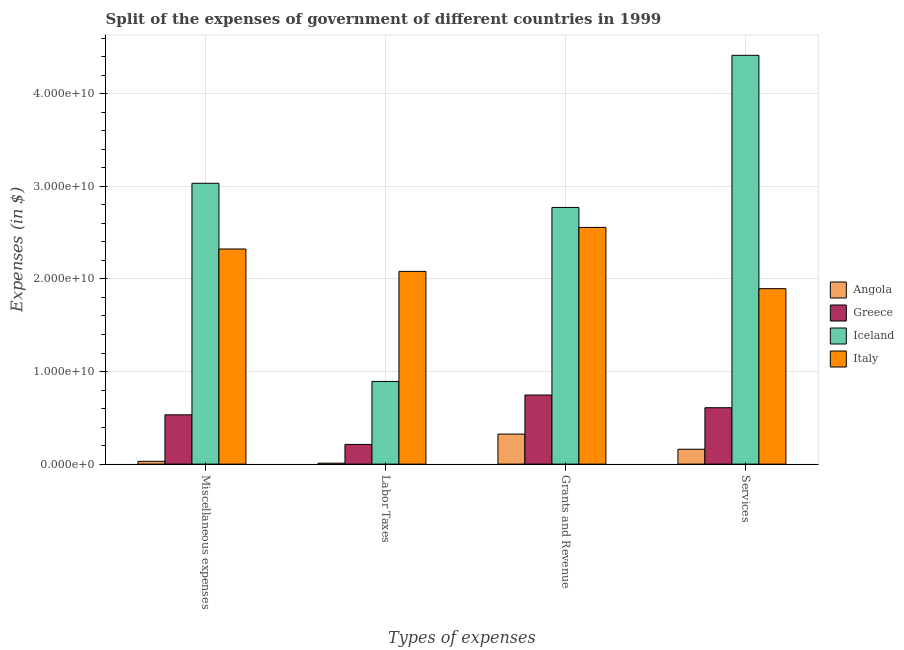How many bars are there on the 1st tick from the right?
Keep it short and to the point. 4. What is the label of the 4th group of bars from the left?
Give a very brief answer. Services. What is the amount spent on grants and revenue in Italy?
Provide a succinct answer. 2.56e+1. Across all countries, what is the maximum amount spent on miscellaneous expenses?
Ensure brevity in your answer.  3.03e+1. Across all countries, what is the minimum amount spent on miscellaneous expenses?
Give a very brief answer. 3.02e+08. In which country was the amount spent on labor taxes maximum?
Provide a succinct answer. Italy. In which country was the amount spent on grants and revenue minimum?
Your answer should be compact. Angola. What is the total amount spent on miscellaneous expenses in the graph?
Make the answer very short. 5.92e+1. What is the difference between the amount spent on grants and revenue in Iceland and that in Angola?
Give a very brief answer. 2.45e+1. What is the difference between the amount spent on labor taxes in Angola and the amount spent on grants and revenue in Italy?
Your response must be concise. -2.55e+1. What is the average amount spent on miscellaneous expenses per country?
Your answer should be compact. 1.48e+1. What is the difference between the amount spent on services and amount spent on labor taxes in Angola?
Your answer should be very brief. 1.50e+09. In how many countries, is the amount spent on miscellaneous expenses greater than 22000000000 $?
Make the answer very short. 2. What is the ratio of the amount spent on labor taxes in Greece to that in Iceland?
Offer a very short reply. 0.24. Is the amount spent on labor taxes in Angola less than that in Greece?
Your answer should be compact. Yes. Is the difference between the amount spent on miscellaneous expenses in Italy and Greece greater than the difference between the amount spent on grants and revenue in Italy and Greece?
Ensure brevity in your answer.  No. What is the difference between the highest and the second highest amount spent on grants and revenue?
Your answer should be very brief. 2.16e+09. What is the difference between the highest and the lowest amount spent on grants and revenue?
Provide a succinct answer. 2.45e+1. In how many countries, is the amount spent on miscellaneous expenses greater than the average amount spent on miscellaneous expenses taken over all countries?
Your response must be concise. 2. What does the 1st bar from the left in Services represents?
Ensure brevity in your answer.  Angola. Is it the case that in every country, the sum of the amount spent on miscellaneous expenses and amount spent on labor taxes is greater than the amount spent on grants and revenue?
Make the answer very short. No. How many countries are there in the graph?
Offer a terse response. 4. Are the values on the major ticks of Y-axis written in scientific E-notation?
Give a very brief answer. Yes. Does the graph contain grids?
Offer a terse response. Yes. How are the legend labels stacked?
Your answer should be very brief. Vertical. What is the title of the graph?
Ensure brevity in your answer.  Split of the expenses of government of different countries in 1999. Does "United States" appear as one of the legend labels in the graph?
Ensure brevity in your answer.  No. What is the label or title of the X-axis?
Make the answer very short. Types of expenses. What is the label or title of the Y-axis?
Ensure brevity in your answer.  Expenses (in $). What is the Expenses (in $) of Angola in Miscellaneous expenses?
Ensure brevity in your answer.  3.02e+08. What is the Expenses (in $) in Greece in Miscellaneous expenses?
Offer a very short reply. 5.32e+09. What is the Expenses (in $) of Iceland in Miscellaneous expenses?
Give a very brief answer. 3.03e+1. What is the Expenses (in $) in Italy in Miscellaneous expenses?
Your response must be concise. 2.32e+1. What is the Expenses (in $) in Angola in Labor Taxes?
Provide a succinct answer. 1.02e+08. What is the Expenses (in $) in Greece in Labor Taxes?
Give a very brief answer. 2.13e+09. What is the Expenses (in $) in Iceland in Labor Taxes?
Your answer should be very brief. 8.93e+09. What is the Expenses (in $) of Italy in Labor Taxes?
Your answer should be compact. 2.08e+1. What is the Expenses (in $) in Angola in Grants and Revenue?
Offer a terse response. 3.24e+09. What is the Expenses (in $) of Greece in Grants and Revenue?
Your answer should be very brief. 7.46e+09. What is the Expenses (in $) in Iceland in Grants and Revenue?
Keep it short and to the point. 2.77e+1. What is the Expenses (in $) of Italy in Grants and Revenue?
Make the answer very short. 2.56e+1. What is the Expenses (in $) of Angola in Services?
Provide a succinct answer. 1.61e+09. What is the Expenses (in $) of Greece in Services?
Offer a very short reply. 6.09e+09. What is the Expenses (in $) in Iceland in Services?
Offer a terse response. 4.42e+1. What is the Expenses (in $) of Italy in Services?
Offer a very short reply. 1.89e+1. Across all Types of expenses, what is the maximum Expenses (in $) in Angola?
Your answer should be compact. 3.24e+09. Across all Types of expenses, what is the maximum Expenses (in $) of Greece?
Ensure brevity in your answer.  7.46e+09. Across all Types of expenses, what is the maximum Expenses (in $) in Iceland?
Make the answer very short. 4.42e+1. Across all Types of expenses, what is the maximum Expenses (in $) in Italy?
Your answer should be very brief. 2.56e+1. Across all Types of expenses, what is the minimum Expenses (in $) of Angola?
Provide a short and direct response. 1.02e+08. Across all Types of expenses, what is the minimum Expenses (in $) of Greece?
Make the answer very short. 2.13e+09. Across all Types of expenses, what is the minimum Expenses (in $) in Iceland?
Keep it short and to the point. 8.93e+09. Across all Types of expenses, what is the minimum Expenses (in $) of Italy?
Your answer should be compact. 1.89e+1. What is the total Expenses (in $) of Angola in the graph?
Make the answer very short. 5.25e+09. What is the total Expenses (in $) in Greece in the graph?
Keep it short and to the point. 2.10e+1. What is the total Expenses (in $) in Iceland in the graph?
Ensure brevity in your answer.  1.11e+11. What is the total Expenses (in $) of Italy in the graph?
Offer a very short reply. 8.86e+1. What is the difference between the Expenses (in $) in Angola in Miscellaneous expenses and that in Labor Taxes?
Offer a very short reply. 2.01e+08. What is the difference between the Expenses (in $) in Greece in Miscellaneous expenses and that in Labor Taxes?
Your answer should be compact. 3.20e+09. What is the difference between the Expenses (in $) in Iceland in Miscellaneous expenses and that in Labor Taxes?
Keep it short and to the point. 2.14e+1. What is the difference between the Expenses (in $) of Italy in Miscellaneous expenses and that in Labor Taxes?
Offer a terse response. 2.42e+09. What is the difference between the Expenses (in $) of Angola in Miscellaneous expenses and that in Grants and Revenue?
Your answer should be compact. -2.94e+09. What is the difference between the Expenses (in $) in Greece in Miscellaneous expenses and that in Grants and Revenue?
Your response must be concise. -2.14e+09. What is the difference between the Expenses (in $) of Iceland in Miscellaneous expenses and that in Grants and Revenue?
Provide a short and direct response. 2.61e+09. What is the difference between the Expenses (in $) of Italy in Miscellaneous expenses and that in Grants and Revenue?
Give a very brief answer. -2.33e+09. What is the difference between the Expenses (in $) in Angola in Miscellaneous expenses and that in Services?
Make the answer very short. -1.30e+09. What is the difference between the Expenses (in $) of Greece in Miscellaneous expenses and that in Services?
Ensure brevity in your answer.  -7.66e+08. What is the difference between the Expenses (in $) of Iceland in Miscellaneous expenses and that in Services?
Your answer should be very brief. -1.38e+1. What is the difference between the Expenses (in $) in Italy in Miscellaneous expenses and that in Services?
Your answer should be very brief. 4.28e+09. What is the difference between the Expenses (in $) in Angola in Labor Taxes and that in Grants and Revenue?
Provide a short and direct response. -3.14e+09. What is the difference between the Expenses (in $) of Greece in Labor Taxes and that in Grants and Revenue?
Provide a succinct answer. -5.33e+09. What is the difference between the Expenses (in $) in Iceland in Labor Taxes and that in Grants and Revenue?
Give a very brief answer. -1.88e+1. What is the difference between the Expenses (in $) of Italy in Labor Taxes and that in Grants and Revenue?
Keep it short and to the point. -4.75e+09. What is the difference between the Expenses (in $) in Angola in Labor Taxes and that in Services?
Provide a succinct answer. -1.50e+09. What is the difference between the Expenses (in $) in Greece in Labor Taxes and that in Services?
Ensure brevity in your answer.  -3.96e+09. What is the difference between the Expenses (in $) in Iceland in Labor Taxes and that in Services?
Make the answer very short. -3.52e+1. What is the difference between the Expenses (in $) in Italy in Labor Taxes and that in Services?
Provide a succinct answer. 1.87e+09. What is the difference between the Expenses (in $) in Angola in Grants and Revenue and that in Services?
Offer a very short reply. 1.64e+09. What is the difference between the Expenses (in $) of Greece in Grants and Revenue and that in Services?
Offer a terse response. 1.37e+09. What is the difference between the Expenses (in $) of Iceland in Grants and Revenue and that in Services?
Make the answer very short. -1.64e+1. What is the difference between the Expenses (in $) of Italy in Grants and Revenue and that in Services?
Ensure brevity in your answer.  6.62e+09. What is the difference between the Expenses (in $) of Angola in Miscellaneous expenses and the Expenses (in $) of Greece in Labor Taxes?
Keep it short and to the point. -1.83e+09. What is the difference between the Expenses (in $) of Angola in Miscellaneous expenses and the Expenses (in $) of Iceland in Labor Taxes?
Offer a very short reply. -8.63e+09. What is the difference between the Expenses (in $) of Angola in Miscellaneous expenses and the Expenses (in $) of Italy in Labor Taxes?
Your answer should be compact. -2.05e+1. What is the difference between the Expenses (in $) in Greece in Miscellaneous expenses and the Expenses (in $) in Iceland in Labor Taxes?
Offer a very short reply. -3.61e+09. What is the difference between the Expenses (in $) in Greece in Miscellaneous expenses and the Expenses (in $) in Italy in Labor Taxes?
Ensure brevity in your answer.  -1.55e+1. What is the difference between the Expenses (in $) of Iceland in Miscellaneous expenses and the Expenses (in $) of Italy in Labor Taxes?
Make the answer very short. 9.52e+09. What is the difference between the Expenses (in $) in Angola in Miscellaneous expenses and the Expenses (in $) in Greece in Grants and Revenue?
Offer a terse response. -7.16e+09. What is the difference between the Expenses (in $) of Angola in Miscellaneous expenses and the Expenses (in $) of Iceland in Grants and Revenue?
Provide a succinct answer. -2.74e+1. What is the difference between the Expenses (in $) of Angola in Miscellaneous expenses and the Expenses (in $) of Italy in Grants and Revenue?
Provide a succinct answer. -2.53e+1. What is the difference between the Expenses (in $) in Greece in Miscellaneous expenses and the Expenses (in $) in Iceland in Grants and Revenue?
Offer a very short reply. -2.24e+1. What is the difference between the Expenses (in $) of Greece in Miscellaneous expenses and the Expenses (in $) of Italy in Grants and Revenue?
Make the answer very short. -2.02e+1. What is the difference between the Expenses (in $) in Iceland in Miscellaneous expenses and the Expenses (in $) in Italy in Grants and Revenue?
Provide a succinct answer. 4.77e+09. What is the difference between the Expenses (in $) of Angola in Miscellaneous expenses and the Expenses (in $) of Greece in Services?
Offer a very short reply. -5.79e+09. What is the difference between the Expenses (in $) in Angola in Miscellaneous expenses and the Expenses (in $) in Iceland in Services?
Give a very brief answer. -4.39e+1. What is the difference between the Expenses (in $) in Angola in Miscellaneous expenses and the Expenses (in $) in Italy in Services?
Your answer should be very brief. -1.86e+1. What is the difference between the Expenses (in $) of Greece in Miscellaneous expenses and the Expenses (in $) of Iceland in Services?
Ensure brevity in your answer.  -3.88e+1. What is the difference between the Expenses (in $) of Greece in Miscellaneous expenses and the Expenses (in $) of Italy in Services?
Offer a very short reply. -1.36e+1. What is the difference between the Expenses (in $) of Iceland in Miscellaneous expenses and the Expenses (in $) of Italy in Services?
Your response must be concise. 1.14e+1. What is the difference between the Expenses (in $) in Angola in Labor Taxes and the Expenses (in $) in Greece in Grants and Revenue?
Give a very brief answer. -7.36e+09. What is the difference between the Expenses (in $) of Angola in Labor Taxes and the Expenses (in $) of Iceland in Grants and Revenue?
Give a very brief answer. -2.76e+1. What is the difference between the Expenses (in $) in Angola in Labor Taxes and the Expenses (in $) in Italy in Grants and Revenue?
Make the answer very short. -2.55e+1. What is the difference between the Expenses (in $) of Greece in Labor Taxes and the Expenses (in $) of Iceland in Grants and Revenue?
Provide a succinct answer. -2.56e+1. What is the difference between the Expenses (in $) of Greece in Labor Taxes and the Expenses (in $) of Italy in Grants and Revenue?
Offer a very short reply. -2.34e+1. What is the difference between the Expenses (in $) in Iceland in Labor Taxes and the Expenses (in $) in Italy in Grants and Revenue?
Ensure brevity in your answer.  -1.66e+1. What is the difference between the Expenses (in $) of Angola in Labor Taxes and the Expenses (in $) of Greece in Services?
Your answer should be compact. -5.99e+09. What is the difference between the Expenses (in $) in Angola in Labor Taxes and the Expenses (in $) in Iceland in Services?
Offer a terse response. -4.41e+1. What is the difference between the Expenses (in $) in Angola in Labor Taxes and the Expenses (in $) in Italy in Services?
Make the answer very short. -1.88e+1. What is the difference between the Expenses (in $) of Greece in Labor Taxes and the Expenses (in $) of Iceland in Services?
Keep it short and to the point. -4.20e+1. What is the difference between the Expenses (in $) in Greece in Labor Taxes and the Expenses (in $) in Italy in Services?
Keep it short and to the point. -1.68e+1. What is the difference between the Expenses (in $) in Iceland in Labor Taxes and the Expenses (in $) in Italy in Services?
Provide a short and direct response. -1.00e+1. What is the difference between the Expenses (in $) of Angola in Grants and Revenue and the Expenses (in $) of Greece in Services?
Keep it short and to the point. -2.85e+09. What is the difference between the Expenses (in $) in Angola in Grants and Revenue and the Expenses (in $) in Iceland in Services?
Provide a succinct answer. -4.09e+1. What is the difference between the Expenses (in $) of Angola in Grants and Revenue and the Expenses (in $) of Italy in Services?
Your answer should be compact. -1.57e+1. What is the difference between the Expenses (in $) of Greece in Grants and Revenue and the Expenses (in $) of Iceland in Services?
Offer a terse response. -3.67e+1. What is the difference between the Expenses (in $) in Greece in Grants and Revenue and the Expenses (in $) in Italy in Services?
Your answer should be very brief. -1.15e+1. What is the difference between the Expenses (in $) in Iceland in Grants and Revenue and the Expenses (in $) in Italy in Services?
Make the answer very short. 8.77e+09. What is the average Expenses (in $) of Angola per Types of expenses?
Your answer should be very brief. 1.31e+09. What is the average Expenses (in $) in Greece per Types of expenses?
Ensure brevity in your answer.  5.25e+09. What is the average Expenses (in $) of Iceland per Types of expenses?
Provide a short and direct response. 2.78e+1. What is the average Expenses (in $) in Italy per Types of expenses?
Offer a terse response. 2.21e+1. What is the difference between the Expenses (in $) in Angola and Expenses (in $) in Greece in Miscellaneous expenses?
Give a very brief answer. -5.02e+09. What is the difference between the Expenses (in $) in Angola and Expenses (in $) in Iceland in Miscellaneous expenses?
Give a very brief answer. -3.00e+1. What is the difference between the Expenses (in $) in Angola and Expenses (in $) in Italy in Miscellaneous expenses?
Offer a very short reply. -2.29e+1. What is the difference between the Expenses (in $) of Greece and Expenses (in $) of Iceland in Miscellaneous expenses?
Offer a very short reply. -2.50e+1. What is the difference between the Expenses (in $) of Greece and Expenses (in $) of Italy in Miscellaneous expenses?
Your answer should be very brief. -1.79e+1. What is the difference between the Expenses (in $) in Iceland and Expenses (in $) in Italy in Miscellaneous expenses?
Give a very brief answer. 7.10e+09. What is the difference between the Expenses (in $) of Angola and Expenses (in $) of Greece in Labor Taxes?
Offer a very short reply. -2.03e+09. What is the difference between the Expenses (in $) in Angola and Expenses (in $) in Iceland in Labor Taxes?
Make the answer very short. -8.83e+09. What is the difference between the Expenses (in $) in Angola and Expenses (in $) in Italy in Labor Taxes?
Offer a terse response. -2.07e+1. What is the difference between the Expenses (in $) of Greece and Expenses (in $) of Iceland in Labor Taxes?
Your answer should be compact. -6.80e+09. What is the difference between the Expenses (in $) of Greece and Expenses (in $) of Italy in Labor Taxes?
Keep it short and to the point. -1.87e+1. What is the difference between the Expenses (in $) of Iceland and Expenses (in $) of Italy in Labor Taxes?
Provide a succinct answer. -1.19e+1. What is the difference between the Expenses (in $) of Angola and Expenses (in $) of Greece in Grants and Revenue?
Your answer should be very brief. -4.22e+09. What is the difference between the Expenses (in $) of Angola and Expenses (in $) of Iceland in Grants and Revenue?
Give a very brief answer. -2.45e+1. What is the difference between the Expenses (in $) of Angola and Expenses (in $) of Italy in Grants and Revenue?
Offer a terse response. -2.23e+1. What is the difference between the Expenses (in $) of Greece and Expenses (in $) of Iceland in Grants and Revenue?
Offer a terse response. -2.03e+1. What is the difference between the Expenses (in $) in Greece and Expenses (in $) in Italy in Grants and Revenue?
Your answer should be very brief. -1.81e+1. What is the difference between the Expenses (in $) in Iceland and Expenses (in $) in Italy in Grants and Revenue?
Provide a succinct answer. 2.16e+09. What is the difference between the Expenses (in $) in Angola and Expenses (in $) in Greece in Services?
Keep it short and to the point. -4.48e+09. What is the difference between the Expenses (in $) of Angola and Expenses (in $) of Iceland in Services?
Offer a very short reply. -4.25e+1. What is the difference between the Expenses (in $) in Angola and Expenses (in $) in Italy in Services?
Make the answer very short. -1.73e+1. What is the difference between the Expenses (in $) in Greece and Expenses (in $) in Iceland in Services?
Keep it short and to the point. -3.81e+1. What is the difference between the Expenses (in $) in Greece and Expenses (in $) in Italy in Services?
Your answer should be compact. -1.29e+1. What is the difference between the Expenses (in $) of Iceland and Expenses (in $) of Italy in Services?
Your response must be concise. 2.52e+1. What is the ratio of the Expenses (in $) of Angola in Miscellaneous expenses to that in Labor Taxes?
Keep it short and to the point. 2.97. What is the ratio of the Expenses (in $) of Greece in Miscellaneous expenses to that in Labor Taxes?
Keep it short and to the point. 2.5. What is the ratio of the Expenses (in $) in Iceland in Miscellaneous expenses to that in Labor Taxes?
Ensure brevity in your answer.  3.4. What is the ratio of the Expenses (in $) of Italy in Miscellaneous expenses to that in Labor Taxes?
Offer a very short reply. 1.12. What is the ratio of the Expenses (in $) of Angola in Miscellaneous expenses to that in Grants and Revenue?
Your answer should be very brief. 0.09. What is the ratio of the Expenses (in $) in Greece in Miscellaneous expenses to that in Grants and Revenue?
Give a very brief answer. 0.71. What is the ratio of the Expenses (in $) of Iceland in Miscellaneous expenses to that in Grants and Revenue?
Offer a terse response. 1.09. What is the ratio of the Expenses (in $) of Italy in Miscellaneous expenses to that in Grants and Revenue?
Your answer should be compact. 0.91. What is the ratio of the Expenses (in $) in Angola in Miscellaneous expenses to that in Services?
Offer a terse response. 0.19. What is the ratio of the Expenses (in $) in Greece in Miscellaneous expenses to that in Services?
Ensure brevity in your answer.  0.87. What is the ratio of the Expenses (in $) of Iceland in Miscellaneous expenses to that in Services?
Your response must be concise. 0.69. What is the ratio of the Expenses (in $) in Italy in Miscellaneous expenses to that in Services?
Offer a terse response. 1.23. What is the ratio of the Expenses (in $) in Angola in Labor Taxes to that in Grants and Revenue?
Give a very brief answer. 0.03. What is the ratio of the Expenses (in $) in Greece in Labor Taxes to that in Grants and Revenue?
Give a very brief answer. 0.29. What is the ratio of the Expenses (in $) of Iceland in Labor Taxes to that in Grants and Revenue?
Keep it short and to the point. 0.32. What is the ratio of the Expenses (in $) in Italy in Labor Taxes to that in Grants and Revenue?
Your answer should be very brief. 0.81. What is the ratio of the Expenses (in $) of Angola in Labor Taxes to that in Services?
Make the answer very short. 0.06. What is the ratio of the Expenses (in $) in Greece in Labor Taxes to that in Services?
Make the answer very short. 0.35. What is the ratio of the Expenses (in $) of Iceland in Labor Taxes to that in Services?
Your answer should be compact. 0.2. What is the ratio of the Expenses (in $) of Italy in Labor Taxes to that in Services?
Make the answer very short. 1.1. What is the ratio of the Expenses (in $) of Angola in Grants and Revenue to that in Services?
Ensure brevity in your answer.  2.02. What is the ratio of the Expenses (in $) of Greece in Grants and Revenue to that in Services?
Offer a very short reply. 1.23. What is the ratio of the Expenses (in $) in Iceland in Grants and Revenue to that in Services?
Make the answer very short. 0.63. What is the ratio of the Expenses (in $) of Italy in Grants and Revenue to that in Services?
Offer a terse response. 1.35. What is the difference between the highest and the second highest Expenses (in $) in Angola?
Offer a very short reply. 1.64e+09. What is the difference between the highest and the second highest Expenses (in $) in Greece?
Provide a succinct answer. 1.37e+09. What is the difference between the highest and the second highest Expenses (in $) in Iceland?
Provide a succinct answer. 1.38e+1. What is the difference between the highest and the second highest Expenses (in $) of Italy?
Give a very brief answer. 2.33e+09. What is the difference between the highest and the lowest Expenses (in $) of Angola?
Your response must be concise. 3.14e+09. What is the difference between the highest and the lowest Expenses (in $) in Greece?
Keep it short and to the point. 5.33e+09. What is the difference between the highest and the lowest Expenses (in $) of Iceland?
Your answer should be compact. 3.52e+1. What is the difference between the highest and the lowest Expenses (in $) in Italy?
Your answer should be compact. 6.62e+09. 